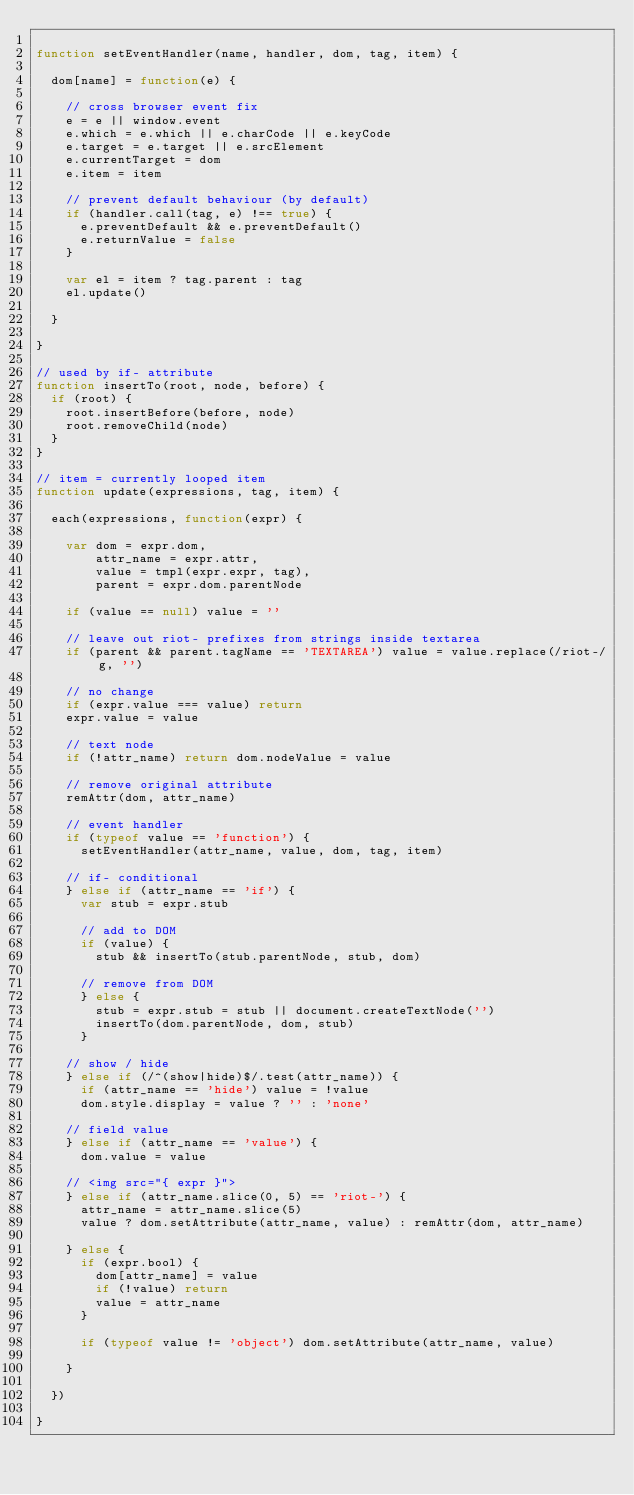<code> <loc_0><loc_0><loc_500><loc_500><_JavaScript_>
function setEventHandler(name, handler, dom, tag, item) {

  dom[name] = function(e) {

    // cross browser event fix
    e = e || window.event
    e.which = e.which || e.charCode || e.keyCode
    e.target = e.target || e.srcElement
    e.currentTarget = dom
    e.item = item

    // prevent default behaviour (by default)
    if (handler.call(tag, e) !== true) {
      e.preventDefault && e.preventDefault()
      e.returnValue = false
    }

    var el = item ? tag.parent : tag
    el.update()

  }

}

// used by if- attribute
function insertTo(root, node, before) {
  if (root) {
    root.insertBefore(before, node)
    root.removeChild(node)
  }
}

// item = currently looped item
function update(expressions, tag, item) {

  each(expressions, function(expr) {

    var dom = expr.dom,
        attr_name = expr.attr,
        value = tmpl(expr.expr, tag),
        parent = expr.dom.parentNode

    if (value == null) value = ''

    // leave out riot- prefixes from strings inside textarea
    if (parent && parent.tagName == 'TEXTAREA') value = value.replace(/riot-/g, '')

    // no change
    if (expr.value === value) return
    expr.value = value

    // text node
    if (!attr_name) return dom.nodeValue = value

    // remove original attribute
    remAttr(dom, attr_name)

    // event handler
    if (typeof value == 'function') {
      setEventHandler(attr_name, value, dom, tag, item)

    // if- conditional
    } else if (attr_name == 'if') {
      var stub = expr.stub

      // add to DOM
      if (value) {
        stub && insertTo(stub.parentNode, stub, dom)

      // remove from DOM
      } else {
        stub = expr.stub = stub || document.createTextNode('')
        insertTo(dom.parentNode, dom, stub)
      }

    // show / hide
    } else if (/^(show|hide)$/.test(attr_name)) {
      if (attr_name == 'hide') value = !value
      dom.style.display = value ? '' : 'none'

    // field value
    } else if (attr_name == 'value') {
      dom.value = value

    // <img src="{ expr }">
    } else if (attr_name.slice(0, 5) == 'riot-') {
      attr_name = attr_name.slice(5)
      value ? dom.setAttribute(attr_name, value) : remAttr(dom, attr_name)

    } else {
      if (expr.bool) {
        dom[attr_name] = value
        if (!value) return
        value = attr_name
      }

      if (typeof value != 'object') dom.setAttribute(attr_name, value)

    }

  })

}</code> 